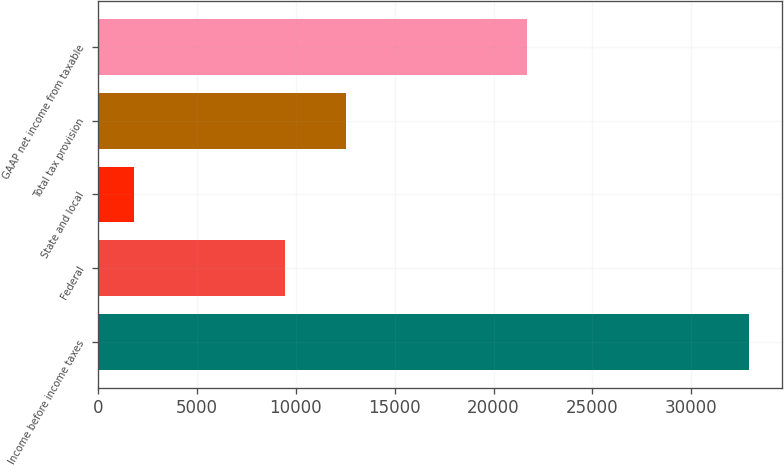Convert chart to OTSL. <chart><loc_0><loc_0><loc_500><loc_500><bar_chart><fcel>Income before income taxes<fcel>Federal<fcel>State and local<fcel>Total tax provision<fcel>GAAP net income from taxable<nl><fcel>32920<fcel>9446<fcel>1808<fcel>12557.2<fcel>21666<nl></chart> 